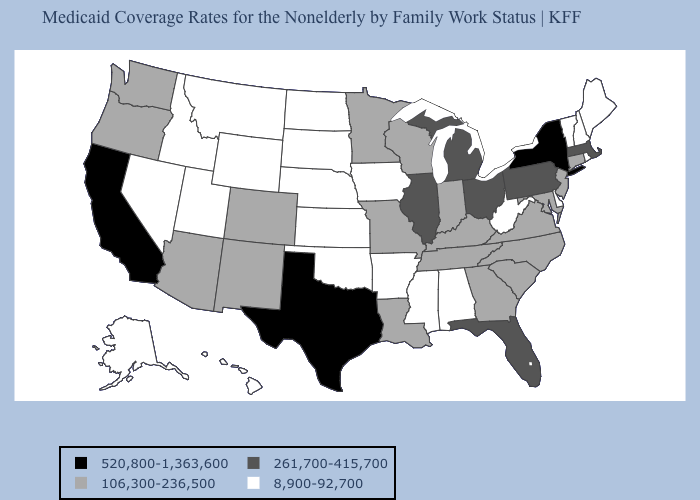Name the states that have a value in the range 261,700-415,700?
Keep it brief. Florida, Illinois, Massachusetts, Michigan, Ohio, Pennsylvania. What is the highest value in the West ?
Be succinct. 520,800-1,363,600. Does the first symbol in the legend represent the smallest category?
Write a very short answer. No. Does Alabama have the lowest value in the USA?
Write a very short answer. Yes. Name the states that have a value in the range 520,800-1,363,600?
Concise answer only. California, New York, Texas. Does Massachusetts have a lower value than New Jersey?
Answer briefly. No. What is the highest value in states that border Arizona?
Keep it brief. 520,800-1,363,600. What is the value of Oklahoma?
Answer briefly. 8,900-92,700. Does Tennessee have the lowest value in the USA?
Answer briefly. No. What is the value of Kentucky?
Answer briefly. 106,300-236,500. How many symbols are there in the legend?
Keep it brief. 4. Is the legend a continuous bar?
Answer briefly. No. Does Arkansas have the lowest value in the South?
Give a very brief answer. Yes. What is the lowest value in the MidWest?
Write a very short answer. 8,900-92,700. 